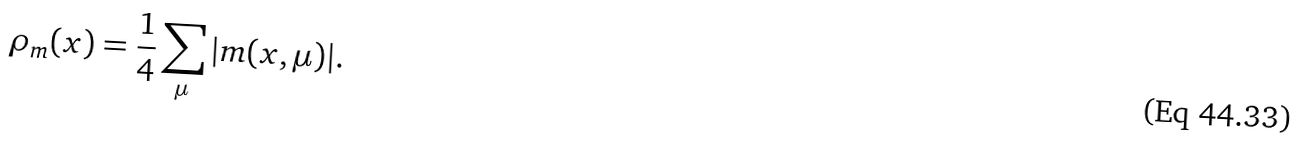Convert formula to latex. <formula><loc_0><loc_0><loc_500><loc_500>\rho _ { m } ( x ) = \frac { 1 } { 4 } \sum _ { \mu } | m ( x , \mu ) | .</formula> 